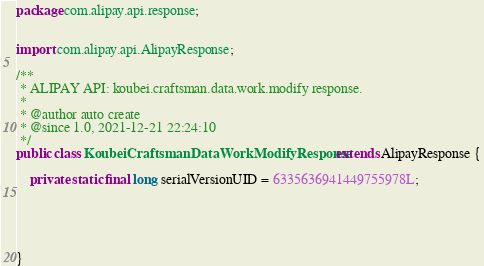Convert code to text. <code><loc_0><loc_0><loc_500><loc_500><_Java_>package com.alipay.api.response;


import com.alipay.api.AlipayResponse;

/**
 * ALIPAY API: koubei.craftsman.data.work.modify response.
 * 
 * @author auto create
 * @since 1.0, 2021-12-21 22:24:10
 */
public class KoubeiCraftsmanDataWorkModifyResponse extends AlipayResponse {

	private static final long serialVersionUID = 6335636941449755978L;

	

	

}
</code> 